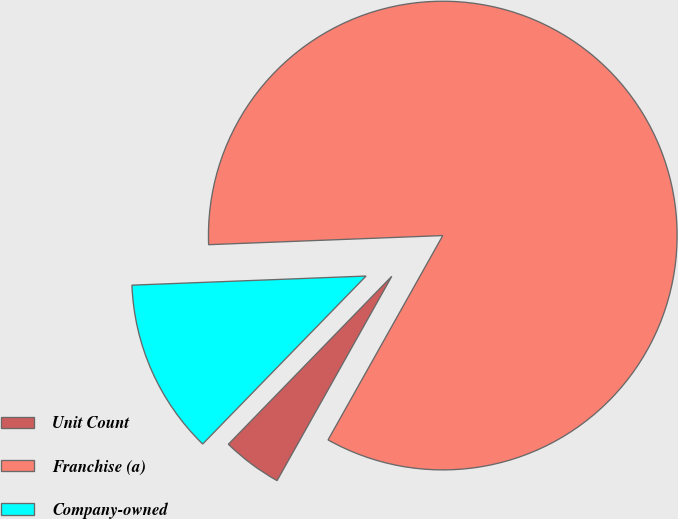Convert chart. <chart><loc_0><loc_0><loc_500><loc_500><pie_chart><fcel>Unit Count<fcel>Franchise (a)<fcel>Company-owned<nl><fcel>4.14%<fcel>83.77%<fcel>12.1%<nl></chart> 